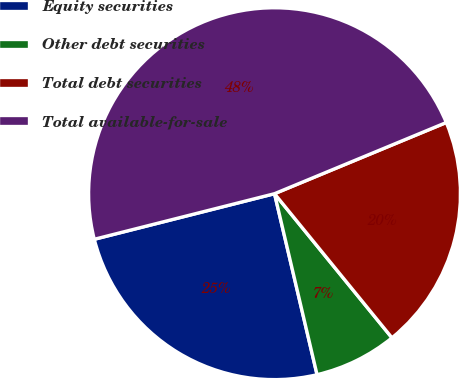Convert chart. <chart><loc_0><loc_0><loc_500><loc_500><pie_chart><fcel>Equity securities<fcel>Other debt securities<fcel>Total debt securities<fcel>Total available-for-sale<nl><fcel>24.73%<fcel>7.21%<fcel>20.37%<fcel>47.69%<nl></chart> 